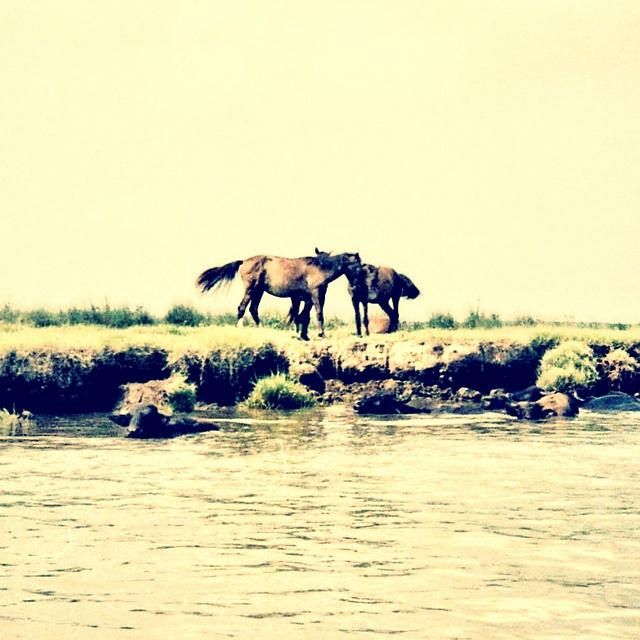How do the horses likely feel towards each other?

Choices:
A) anxious
B) threatened
C) friendly
D) angry friendly 